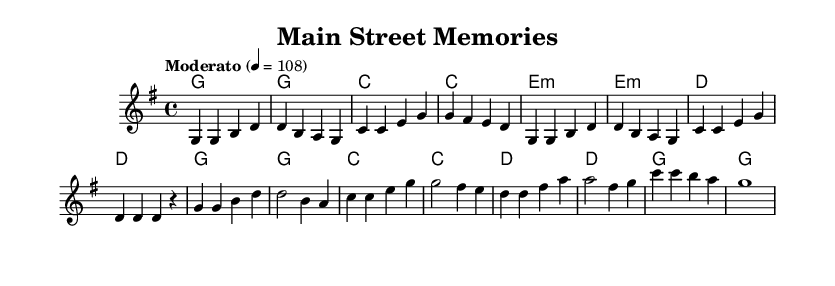What is the key signature of this music? The key signature is G major, which has one sharp (F#). It can be identified from the key signature symbol at the beginning of the music.
Answer: G major What is the time signature of the piece? The time signature is 4/4, indicated by the notation shown at the beginning of the score which allows four beats per measure.
Answer: 4/4 What is the tempo marking for this music? The tempo marking is "Moderato," denoting a moderate speed. This is specified in the tempo indication line within the score.
Answer: Moderato How many measures are in the verse section? The verse section consists of 8 measures, which can be counted from the musical notation provided, as there are 8 complete bars before moving to the chorus.
Answer: 8 What is the first chord of the chorus? The first chord of the chorus is G major, which can be identified by looking at the chord names above the melody from the start of the chorus section.
Answer: G major What is the relationship between the melody's first note and the chord underneath? The first note of the melody is G, which is the root note of the G major chord indicated below it, thereby establishing harmonic support.
Answer: Root note What characteristic demonstrates the nostalgic theme of the song? The structure and harmony of the song feature simple chord progressions and familiar melodic lines, common in nostalgic country rock tunes, reflecting small-town roots and values.
Answer: Simple harmonies 